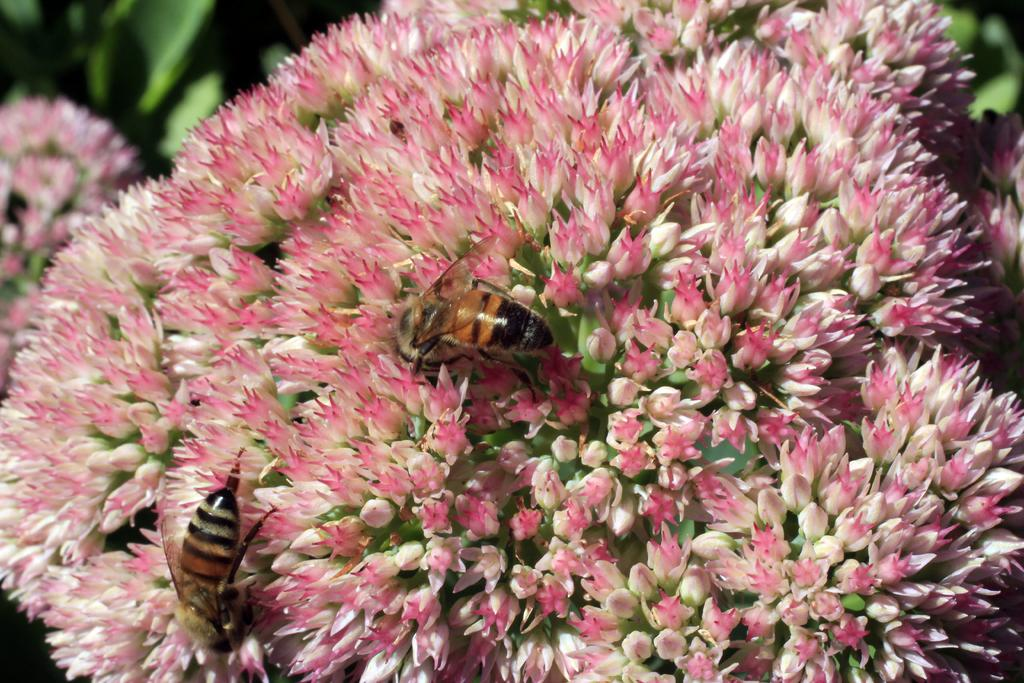What color are the flowers in the image? The flowers in the image are pink. Where are the flowers located? The flowers are on plants. Are there any insects present in the image? Yes, there are two honey bees on the flowers. What colors are the honey bees? The honey bees are in black and brown color. What is the weight of the pot in the image? There is no pot present in the image. Can you tell me how many cans are visible in the image? There are no cans visible in the image. 